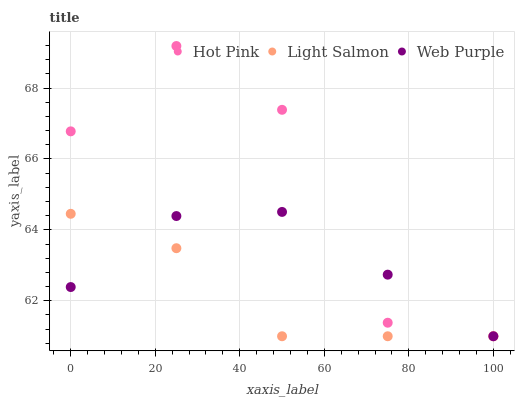Does Light Salmon have the minimum area under the curve?
Answer yes or no. Yes. Does Hot Pink have the maximum area under the curve?
Answer yes or no. Yes. Does Web Purple have the minimum area under the curve?
Answer yes or no. No. Does Web Purple have the maximum area under the curve?
Answer yes or no. No. Is Web Purple the smoothest?
Answer yes or no. Yes. Is Hot Pink the roughest?
Answer yes or no. Yes. Is Hot Pink the smoothest?
Answer yes or no. No. Is Web Purple the roughest?
Answer yes or no. No. Does Light Salmon have the lowest value?
Answer yes or no. Yes. Does Hot Pink have the highest value?
Answer yes or no. Yes. Does Web Purple have the highest value?
Answer yes or no. No. Does Web Purple intersect Light Salmon?
Answer yes or no. Yes. Is Web Purple less than Light Salmon?
Answer yes or no. No. Is Web Purple greater than Light Salmon?
Answer yes or no. No. 